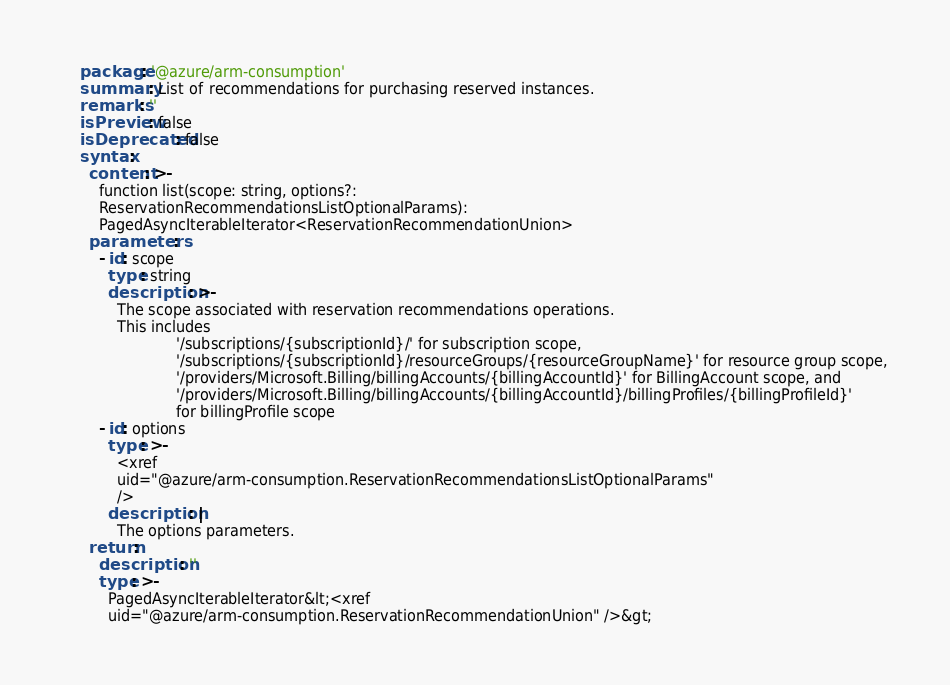<code> <loc_0><loc_0><loc_500><loc_500><_YAML_>    package: '@azure/arm-consumption'
    summary: List of recommendations for purchasing reserved instances.
    remarks: ''
    isPreview: false
    isDeprecated: false
    syntax:
      content: >-
        function list(scope: string, options?:
        ReservationRecommendationsListOptionalParams):
        PagedAsyncIterableIterator<ReservationRecommendationUnion>
      parameters:
        - id: scope
          type: string
          description: >-
            The scope associated with reservation recommendations operations.
            This includes
                         '/subscriptions/{subscriptionId}/' for subscription scope,
                         '/subscriptions/{subscriptionId}/resourceGroups/{resourceGroupName}' for resource group scope,
                         '/providers/Microsoft.Billing/billingAccounts/{billingAccountId}' for BillingAccount scope, and
                         '/providers/Microsoft.Billing/billingAccounts/{billingAccountId}/billingProfiles/{billingProfileId}'
                         for billingProfile scope
        - id: options
          type: >-
            <xref
            uid="@azure/arm-consumption.ReservationRecommendationsListOptionalParams"
            />
          description: |
            The options parameters.
      return:
        description: ''
        type: >-
          PagedAsyncIterableIterator&lt;<xref
          uid="@azure/arm-consumption.ReservationRecommendationUnion" />&gt;
</code> 